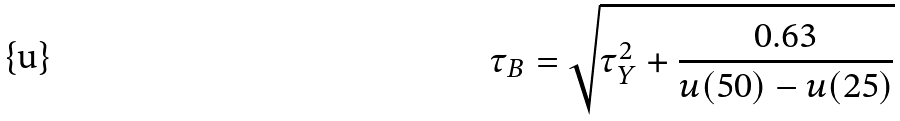Convert formula to latex. <formula><loc_0><loc_0><loc_500><loc_500>\tau _ { B } = \sqrt { \tau _ { Y } ^ { 2 } + \frac { 0 . 6 3 } { u ( 5 0 ) - u ( 2 5 ) } }</formula> 